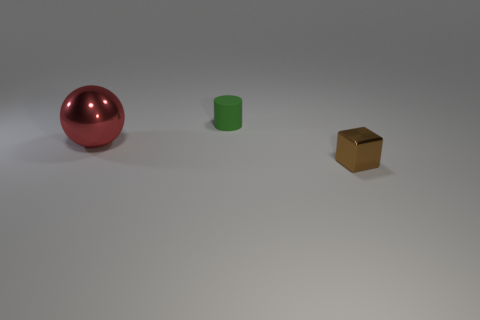How many large objects are either cylinders or brown cylinders?
Make the answer very short. 0. Is the number of tiny cylinders that are behind the small brown thing greater than the number of small brown shiny blocks right of the green rubber object?
Give a very brief answer. No. What number of other objects are there of the same size as the brown cube?
Provide a succinct answer. 1. Is the material of the object behind the ball the same as the small brown cube?
Offer a terse response. No. What number of other objects are there of the same color as the large metal ball?
Give a very brief answer. 0. How many other objects are the same shape as the big red metal object?
Make the answer very short. 0. Are there the same number of matte cylinders that are on the left side of the matte cylinder and small brown shiny cubes that are in front of the big red thing?
Give a very brief answer. No. There is a tiny thing that is in front of the small thing behind the metal object that is on the right side of the large shiny sphere; what shape is it?
Your response must be concise. Cube. Is the thing to the left of the small green rubber cylinder made of the same material as the small thing that is on the right side of the matte cylinder?
Your answer should be very brief. Yes. There is a small green thing behind the large shiny ball; what is its shape?
Provide a short and direct response. Cylinder. 